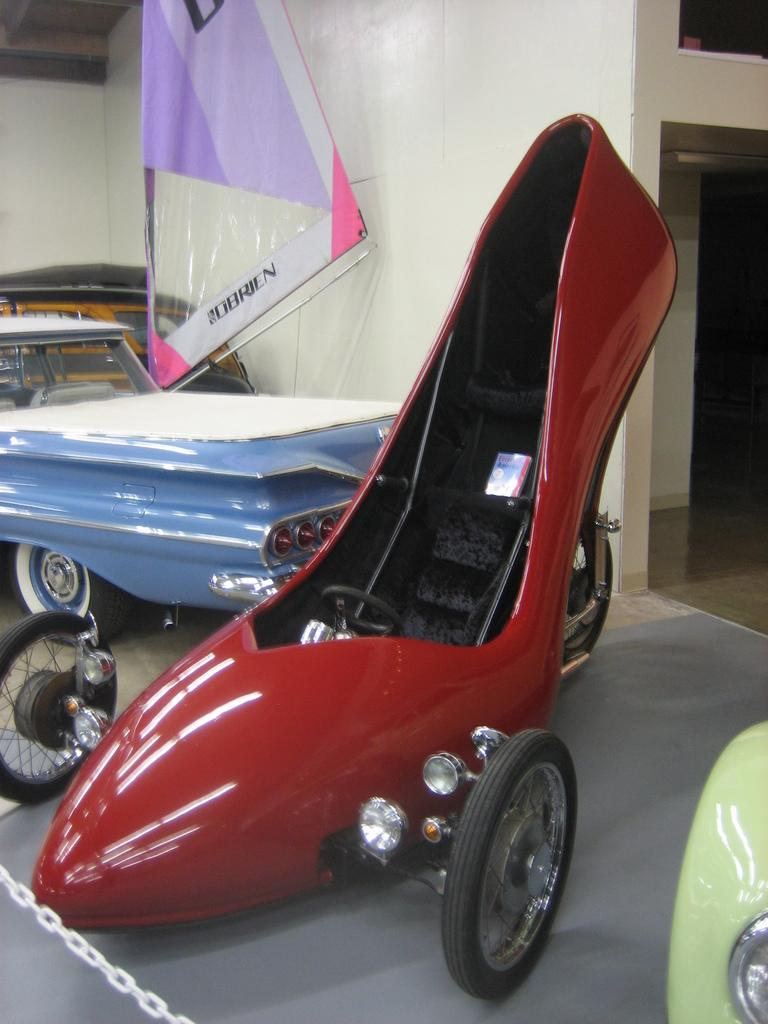What is the main subject in the center of the image? There are vehicles in the center of the image. What can be seen in the background of the image? There is a wall in the background of the image. What is the downtown area like in the image? There is no downtown area present in the image; it only features vehicles and a wall. What type of trade is happening in the image? There is no trade happening in the image; it only features vehicles and a wall. 